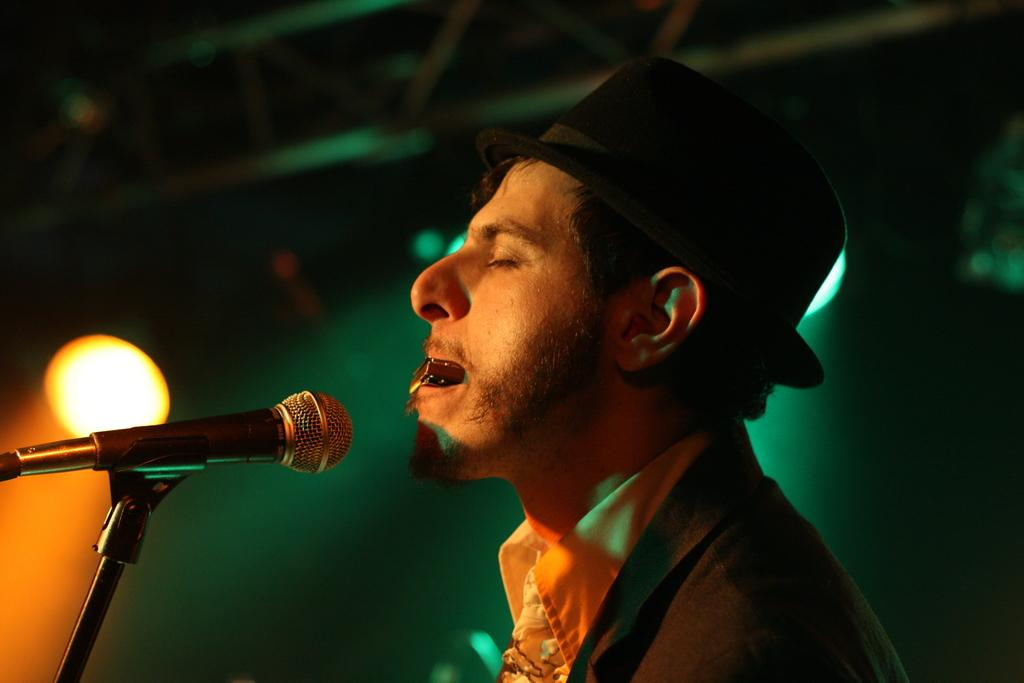What is the main subject of the image? The main subject of the image is a man. What is the man holding in the image? The man is holding an object. Can you describe the man's attire? The man is wearing a hat. What equipment is present in front of the man? There is a microphone with a stand in front of the man. How would you describe the lighting conditions in the image? The background of the image is dark, but there are lights visible in the background. What type of tax is the man discussing in the image? There is no indication in the image that the man is discussing any type of tax. Can you see the man's daughter in the image? There is no mention of a daughter in the image, and no other person is visible besides the man. 